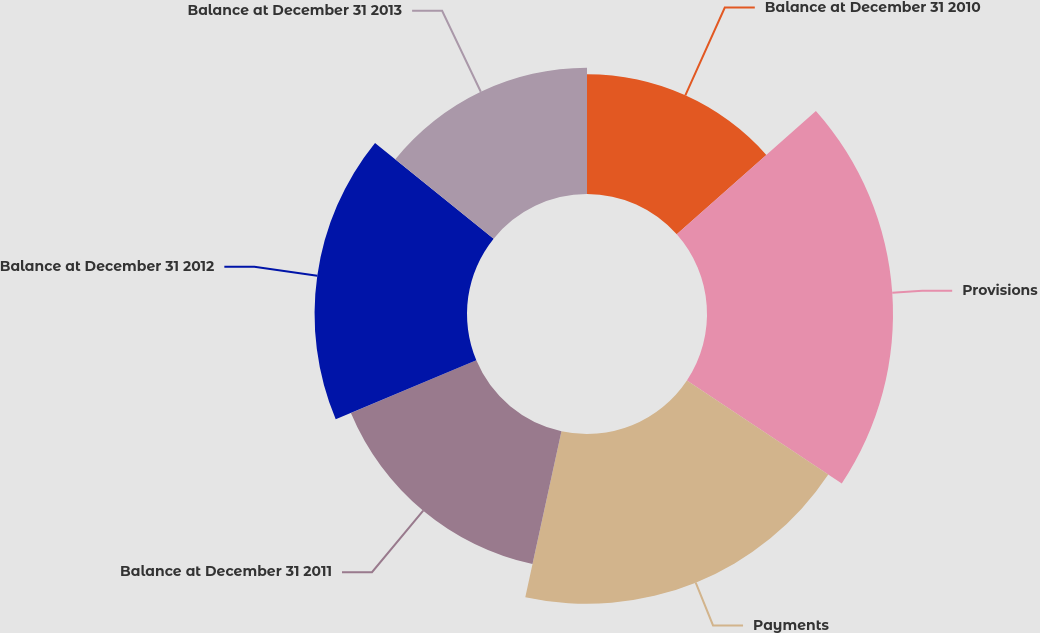Convert chart. <chart><loc_0><loc_0><loc_500><loc_500><pie_chart><fcel>Balance at December 31 2010<fcel>Provisions<fcel>Payments<fcel>Balance at December 31 2011<fcel>Balance at December 31 2012<fcel>Balance at December 31 2013<nl><fcel>13.45%<fcel>20.89%<fcel>19.07%<fcel>15.27%<fcel>17.12%<fcel>14.19%<nl></chart> 